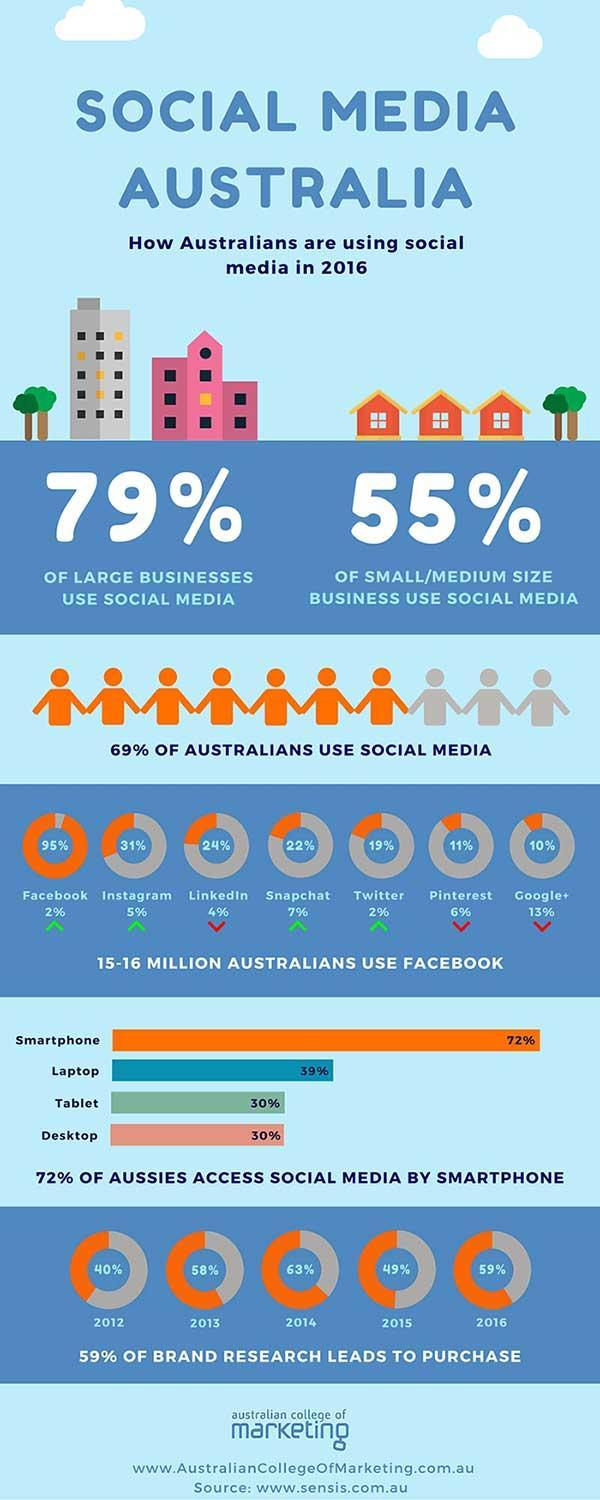What is the brand research percentage in the year 2013?
Answer the question with a short phrase. 58% What is the australian population that uses facebook in the year 2016? 15-16 MILLION Which year shows the least brand research percent? 2012 What percentage of large businesses do not use social media? 21% Which year is the brand research percent highest? 2014 What percentage of australians do not use social media? 31% 